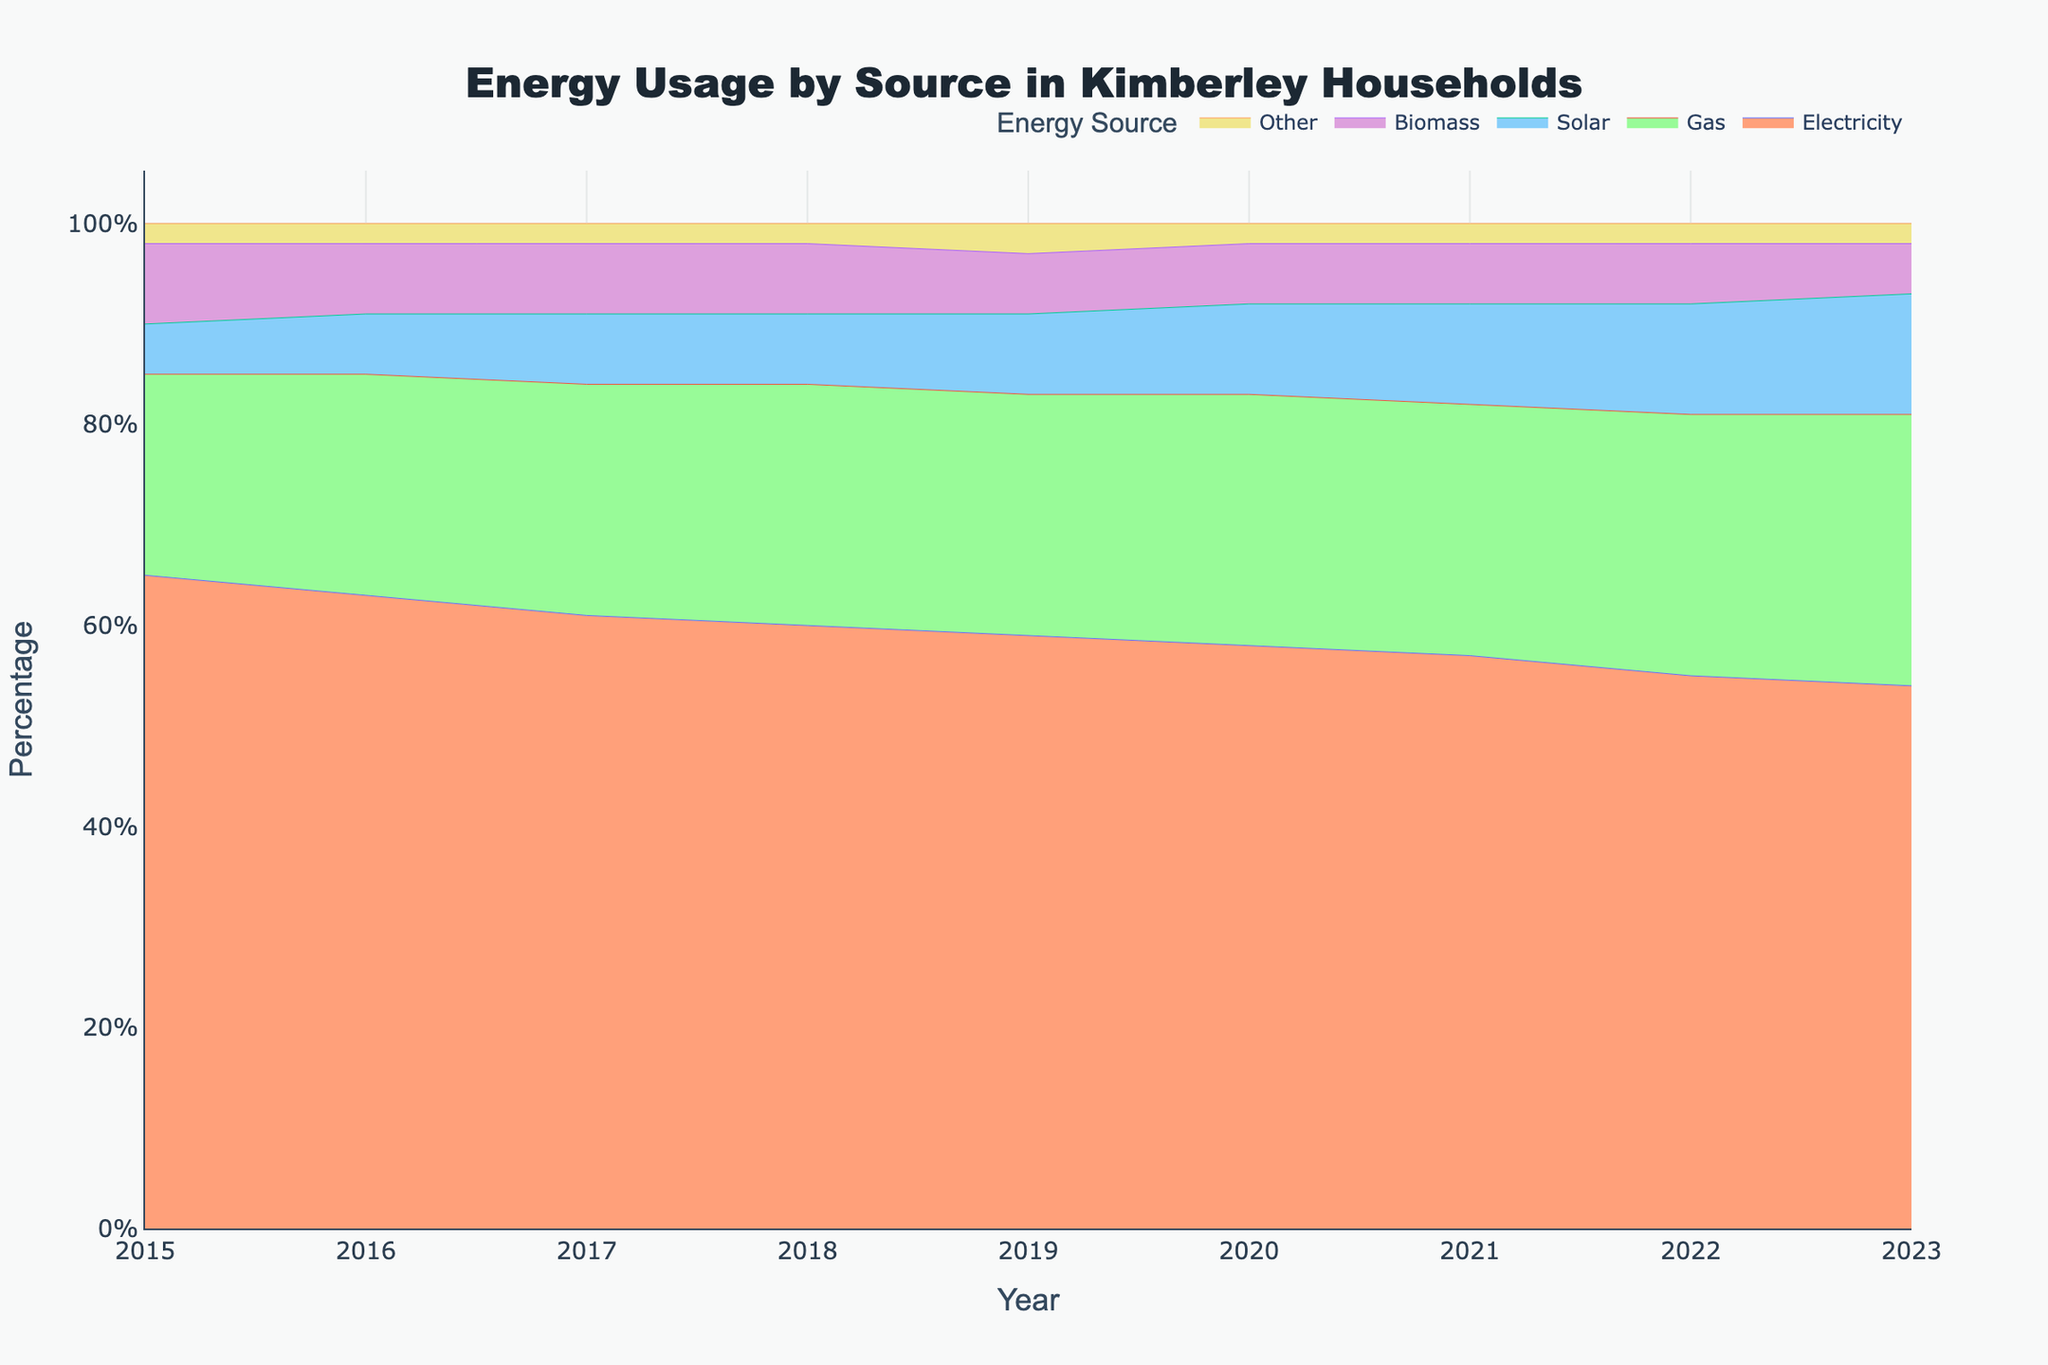What is the main title of the chart? The main title is displayed at the top of the chart.
Answer: Energy Usage by Source in Kimberley Households What is the trend in electricity use from 2015 to 2023? Observe the line representing electricity. It begins at the highest percentage in 2015 and decreases consistently each year until 2023.
Answer: Decreasing Which energy source shows a consistent increase in usage over the years? Look at the lines for each energy source; the one that steadily climbs each year indicates the consistent increase.
Answer: Solar In what year does gas usage surpass 25% of total energy usage? Identify the line for gas and observe the point where it crosses the 25% mark on the y-axis.
Answer: 2020 How did biomass usage change from 2015 to 2023? Observe the line for biomass from 2015 to 2023; note its start and end points and any fluctuations.
Answer: Decreased Which energy source showed the least change in usage from 2015 to 2023? Compare the lines representing each energy source, looking for the one with the smallest fluctuation or range.
Answer: Other What is the percentage use of solar energy in 2018? Look at the point on the solar energy line for the year 2018 and note its corresponding percentage on the y-axis.
Answer: 7% In which year did electricity usage drop below 60%? Identify the electricity line and find the first point where it is below the 60% mark on the y-axis.
Answer: 2019 Compare the usage of gas and electricity in 2023. Which one is higher? Look at the points on the lines for gas and electricity for the year 2023 and compare their values.
Answer: Gas If the trend continues, which energy source is likely to overtake electricity as the most used by 2030? Estimate the future trends by extending the current slopes of the lines; identify which energy source's trend line might intersect with or surpass electricity the earliest.
Answer: Gas 